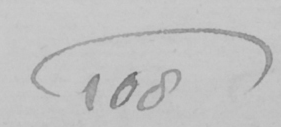Please provide the text content of this handwritten line. 108 